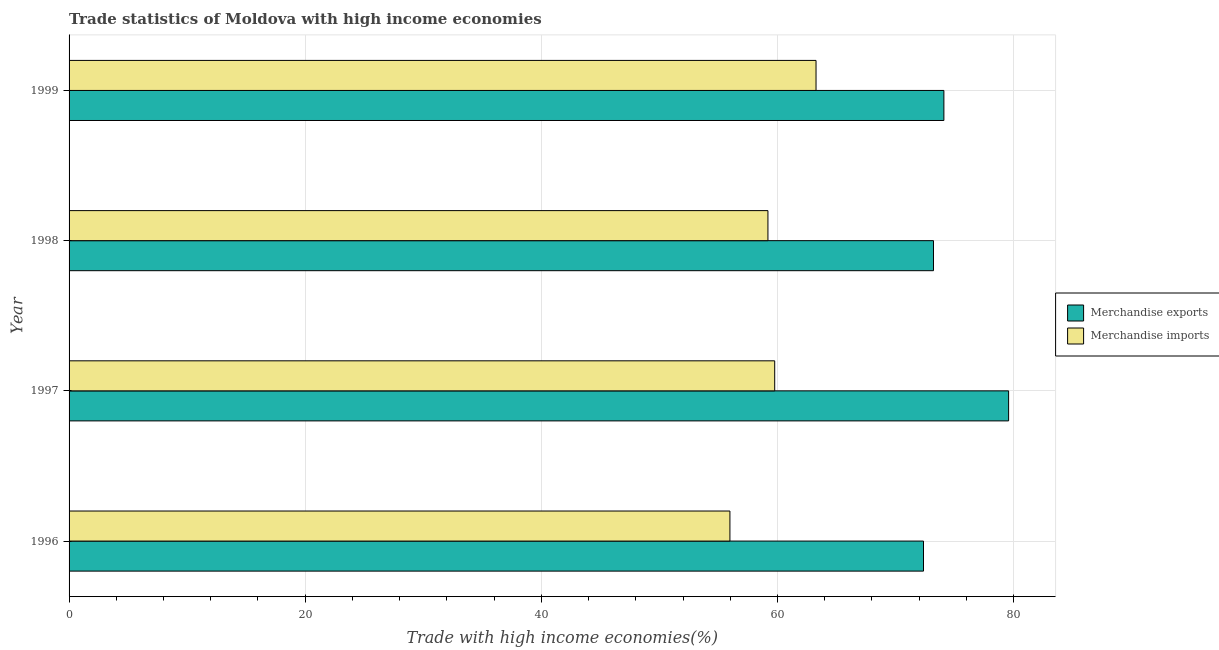How many different coloured bars are there?
Your answer should be very brief. 2. How many groups of bars are there?
Offer a very short reply. 4. What is the label of the 4th group of bars from the top?
Make the answer very short. 1996. In how many cases, is the number of bars for a given year not equal to the number of legend labels?
Offer a very short reply. 0. What is the merchandise imports in 1998?
Your answer should be very brief. 59.19. Across all years, what is the maximum merchandise exports?
Offer a very short reply. 79.57. Across all years, what is the minimum merchandise imports?
Make the answer very short. 55.97. In which year was the merchandise imports maximum?
Offer a terse response. 1999. What is the total merchandise exports in the graph?
Give a very brief answer. 299.24. What is the difference between the merchandise exports in 1997 and that in 1998?
Your response must be concise. 6.36. What is the difference between the merchandise imports in 1999 and the merchandise exports in 1997?
Provide a succinct answer. -16.31. What is the average merchandise exports per year?
Provide a short and direct response. 74.81. In the year 1997, what is the difference between the merchandise exports and merchandise imports?
Provide a short and direct response. 19.81. What is the ratio of the merchandise exports in 1997 to that in 1998?
Give a very brief answer. 1.09. Is the merchandise exports in 1998 less than that in 1999?
Offer a very short reply. Yes. Is the difference between the merchandise exports in 1996 and 1998 greater than the difference between the merchandise imports in 1996 and 1998?
Offer a very short reply. Yes. What is the difference between the highest and the second highest merchandise exports?
Offer a very short reply. 5.48. What is the difference between the highest and the lowest merchandise exports?
Provide a succinct answer. 7.21. In how many years, is the merchandise imports greater than the average merchandise imports taken over all years?
Provide a succinct answer. 2. Is the sum of the merchandise exports in 1996 and 1997 greater than the maximum merchandise imports across all years?
Keep it short and to the point. Yes. What does the 2nd bar from the top in 1999 represents?
Make the answer very short. Merchandise exports. What does the 2nd bar from the bottom in 1996 represents?
Give a very brief answer. Merchandise imports. What is the difference between two consecutive major ticks on the X-axis?
Give a very brief answer. 20. Are the values on the major ticks of X-axis written in scientific E-notation?
Keep it short and to the point. No. Does the graph contain any zero values?
Your response must be concise. No. How are the legend labels stacked?
Provide a succinct answer. Vertical. What is the title of the graph?
Ensure brevity in your answer.  Trade statistics of Moldova with high income economies. What is the label or title of the X-axis?
Provide a succinct answer. Trade with high income economies(%). What is the Trade with high income economies(%) in Merchandise exports in 1996?
Your answer should be compact. 72.36. What is the Trade with high income economies(%) of Merchandise imports in 1996?
Offer a terse response. 55.97. What is the Trade with high income economies(%) in Merchandise exports in 1997?
Give a very brief answer. 79.57. What is the Trade with high income economies(%) of Merchandise imports in 1997?
Provide a short and direct response. 59.76. What is the Trade with high income economies(%) of Merchandise exports in 1998?
Offer a very short reply. 73.21. What is the Trade with high income economies(%) in Merchandise imports in 1998?
Offer a very short reply. 59.19. What is the Trade with high income economies(%) in Merchandise exports in 1999?
Provide a short and direct response. 74.09. What is the Trade with high income economies(%) of Merchandise imports in 1999?
Your answer should be very brief. 63.26. Across all years, what is the maximum Trade with high income economies(%) of Merchandise exports?
Give a very brief answer. 79.57. Across all years, what is the maximum Trade with high income economies(%) of Merchandise imports?
Provide a succinct answer. 63.26. Across all years, what is the minimum Trade with high income economies(%) of Merchandise exports?
Your answer should be very brief. 72.36. Across all years, what is the minimum Trade with high income economies(%) in Merchandise imports?
Give a very brief answer. 55.97. What is the total Trade with high income economies(%) of Merchandise exports in the graph?
Provide a succinct answer. 299.24. What is the total Trade with high income economies(%) of Merchandise imports in the graph?
Ensure brevity in your answer.  238.19. What is the difference between the Trade with high income economies(%) of Merchandise exports in 1996 and that in 1997?
Ensure brevity in your answer.  -7.21. What is the difference between the Trade with high income economies(%) of Merchandise imports in 1996 and that in 1997?
Give a very brief answer. -3.79. What is the difference between the Trade with high income economies(%) of Merchandise exports in 1996 and that in 1998?
Your answer should be compact. -0.85. What is the difference between the Trade with high income economies(%) in Merchandise imports in 1996 and that in 1998?
Your answer should be compact. -3.22. What is the difference between the Trade with high income economies(%) in Merchandise exports in 1996 and that in 1999?
Give a very brief answer. -1.73. What is the difference between the Trade with high income economies(%) of Merchandise imports in 1996 and that in 1999?
Give a very brief answer. -7.29. What is the difference between the Trade with high income economies(%) in Merchandise exports in 1997 and that in 1998?
Your answer should be very brief. 6.36. What is the difference between the Trade with high income economies(%) of Merchandise imports in 1997 and that in 1998?
Give a very brief answer. 0.57. What is the difference between the Trade with high income economies(%) in Merchandise exports in 1997 and that in 1999?
Provide a short and direct response. 5.48. What is the difference between the Trade with high income economies(%) of Merchandise imports in 1997 and that in 1999?
Provide a succinct answer. -3.5. What is the difference between the Trade with high income economies(%) of Merchandise exports in 1998 and that in 1999?
Your answer should be very brief. -0.88. What is the difference between the Trade with high income economies(%) of Merchandise imports in 1998 and that in 1999?
Give a very brief answer. -4.07. What is the difference between the Trade with high income economies(%) of Merchandise exports in 1996 and the Trade with high income economies(%) of Merchandise imports in 1997?
Offer a very short reply. 12.6. What is the difference between the Trade with high income economies(%) of Merchandise exports in 1996 and the Trade with high income economies(%) of Merchandise imports in 1998?
Offer a very short reply. 13.17. What is the difference between the Trade with high income economies(%) in Merchandise exports in 1996 and the Trade with high income economies(%) in Merchandise imports in 1999?
Your answer should be compact. 9.1. What is the difference between the Trade with high income economies(%) of Merchandise exports in 1997 and the Trade with high income economies(%) of Merchandise imports in 1998?
Keep it short and to the point. 20.38. What is the difference between the Trade with high income economies(%) of Merchandise exports in 1997 and the Trade with high income economies(%) of Merchandise imports in 1999?
Make the answer very short. 16.31. What is the difference between the Trade with high income economies(%) of Merchandise exports in 1998 and the Trade with high income economies(%) of Merchandise imports in 1999?
Your answer should be very brief. 9.95. What is the average Trade with high income economies(%) in Merchandise exports per year?
Provide a short and direct response. 74.81. What is the average Trade with high income economies(%) of Merchandise imports per year?
Keep it short and to the point. 59.55. In the year 1996, what is the difference between the Trade with high income economies(%) of Merchandise exports and Trade with high income economies(%) of Merchandise imports?
Keep it short and to the point. 16.39. In the year 1997, what is the difference between the Trade with high income economies(%) of Merchandise exports and Trade with high income economies(%) of Merchandise imports?
Provide a short and direct response. 19.81. In the year 1998, what is the difference between the Trade with high income economies(%) in Merchandise exports and Trade with high income economies(%) in Merchandise imports?
Ensure brevity in your answer.  14.02. In the year 1999, what is the difference between the Trade with high income economies(%) of Merchandise exports and Trade with high income economies(%) of Merchandise imports?
Your response must be concise. 10.83. What is the ratio of the Trade with high income economies(%) of Merchandise exports in 1996 to that in 1997?
Offer a very short reply. 0.91. What is the ratio of the Trade with high income economies(%) of Merchandise imports in 1996 to that in 1997?
Offer a terse response. 0.94. What is the ratio of the Trade with high income economies(%) of Merchandise exports in 1996 to that in 1998?
Your answer should be compact. 0.99. What is the ratio of the Trade with high income economies(%) in Merchandise imports in 1996 to that in 1998?
Your answer should be compact. 0.95. What is the ratio of the Trade with high income economies(%) in Merchandise exports in 1996 to that in 1999?
Your answer should be compact. 0.98. What is the ratio of the Trade with high income economies(%) of Merchandise imports in 1996 to that in 1999?
Your response must be concise. 0.88. What is the ratio of the Trade with high income economies(%) of Merchandise exports in 1997 to that in 1998?
Offer a very short reply. 1.09. What is the ratio of the Trade with high income economies(%) in Merchandise imports in 1997 to that in 1998?
Your answer should be very brief. 1.01. What is the ratio of the Trade with high income economies(%) of Merchandise exports in 1997 to that in 1999?
Your response must be concise. 1.07. What is the ratio of the Trade with high income economies(%) of Merchandise imports in 1997 to that in 1999?
Provide a short and direct response. 0.94. What is the ratio of the Trade with high income economies(%) in Merchandise imports in 1998 to that in 1999?
Offer a terse response. 0.94. What is the difference between the highest and the second highest Trade with high income economies(%) in Merchandise exports?
Offer a terse response. 5.48. What is the difference between the highest and the second highest Trade with high income economies(%) of Merchandise imports?
Your response must be concise. 3.5. What is the difference between the highest and the lowest Trade with high income economies(%) of Merchandise exports?
Offer a very short reply. 7.21. What is the difference between the highest and the lowest Trade with high income economies(%) in Merchandise imports?
Make the answer very short. 7.29. 